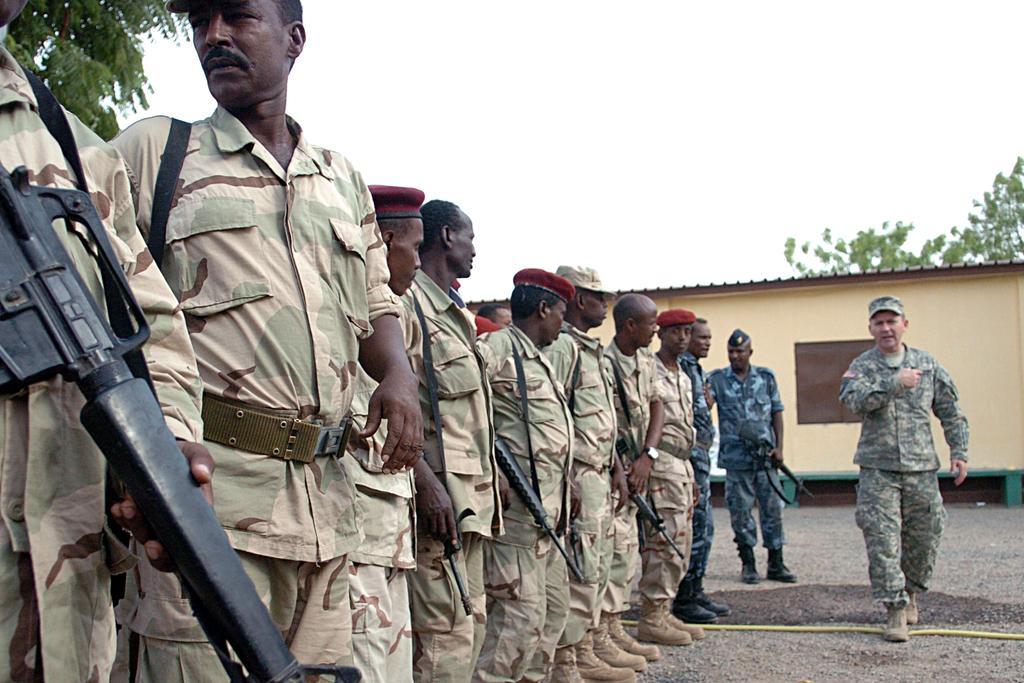Describe this image in one or two sentences. On the right there is a man who is wearing cap, shirt, trouser and shoe. He is standing near to the rope. On the left we can see the group of persons were standing in the line. They are wearing the same dress and holding the gun. In the background we can see the shed and trees. At the top there is a sky. 